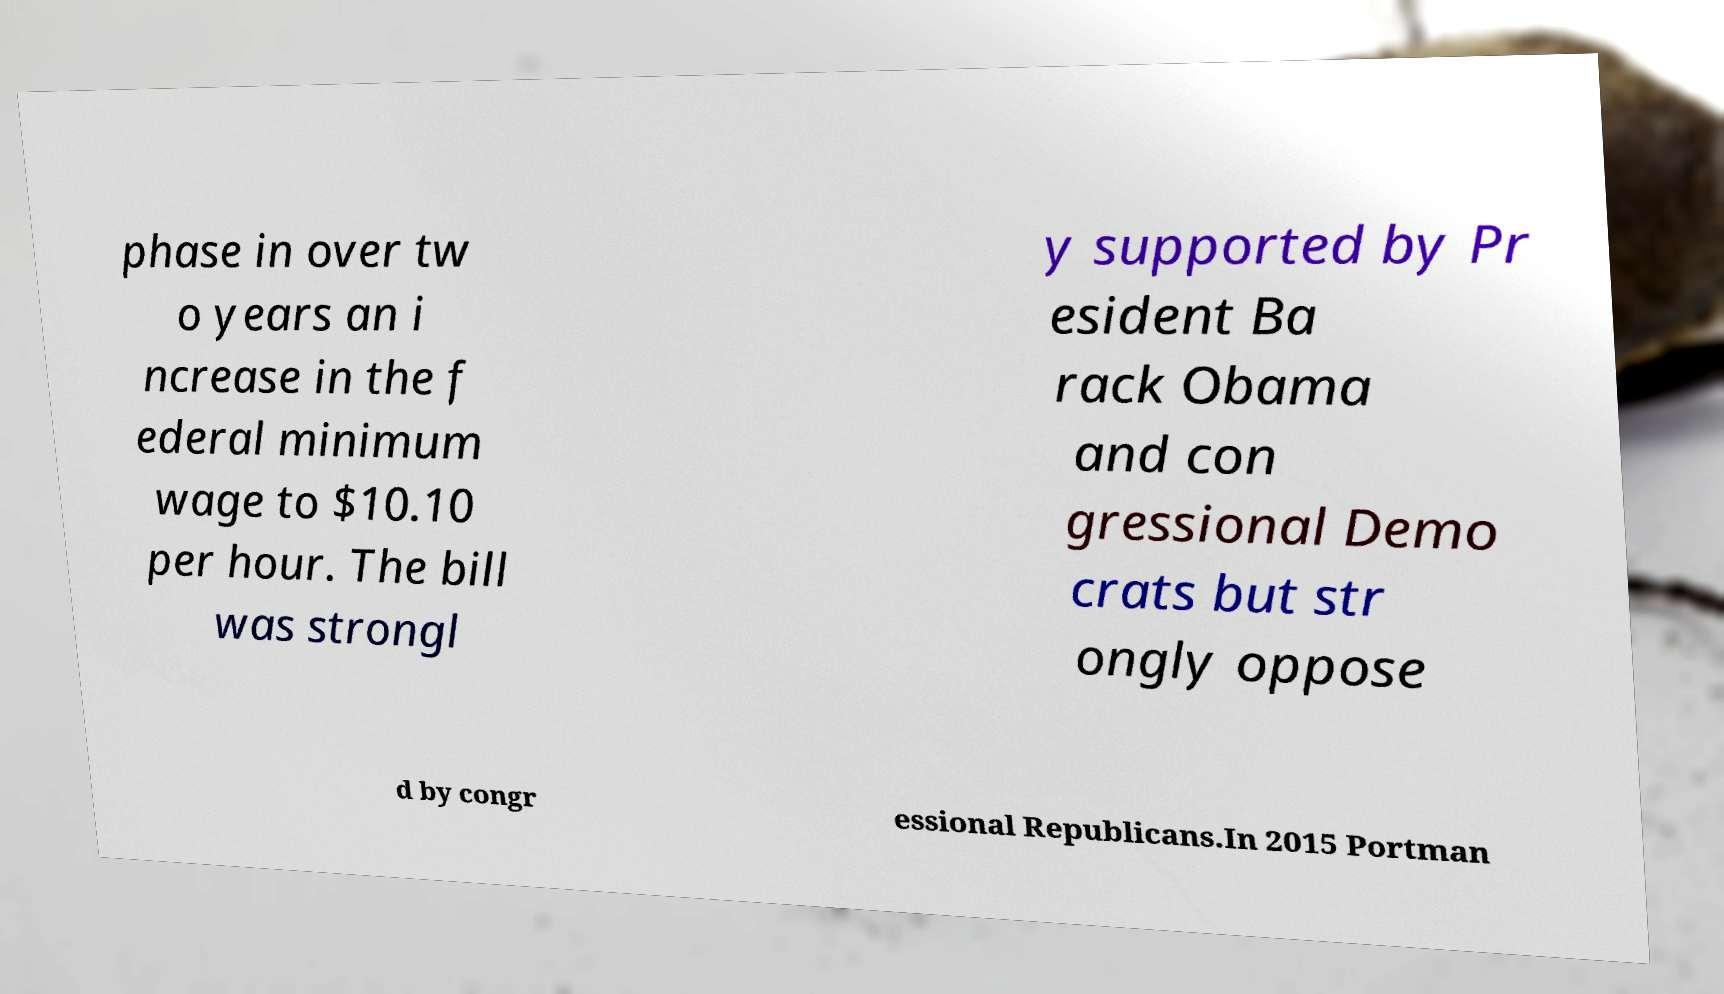I need the written content from this picture converted into text. Can you do that? phase in over tw o years an i ncrease in the f ederal minimum wage to $10.10 per hour. The bill was strongl y supported by Pr esident Ba rack Obama and con gressional Demo crats but str ongly oppose d by congr essional Republicans.In 2015 Portman 